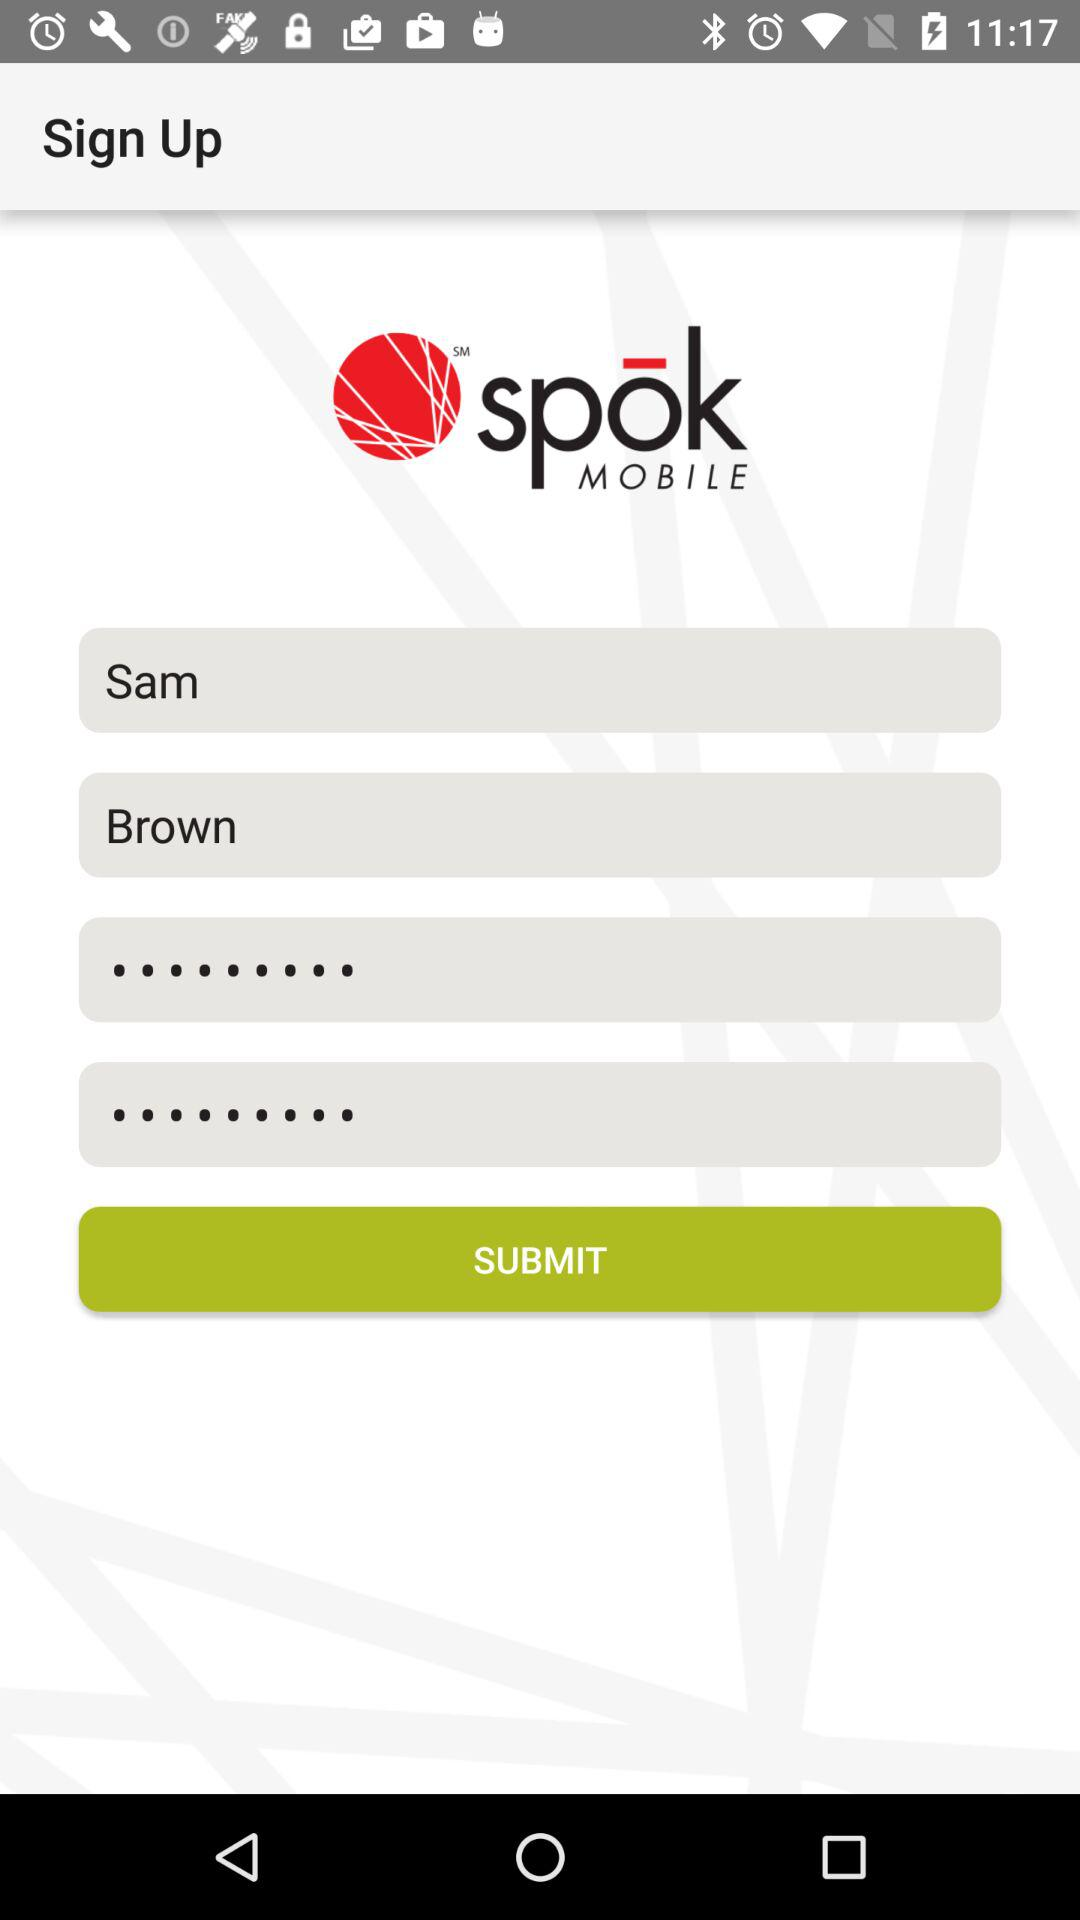What is the application name? The application name is "spok MOBILE". 